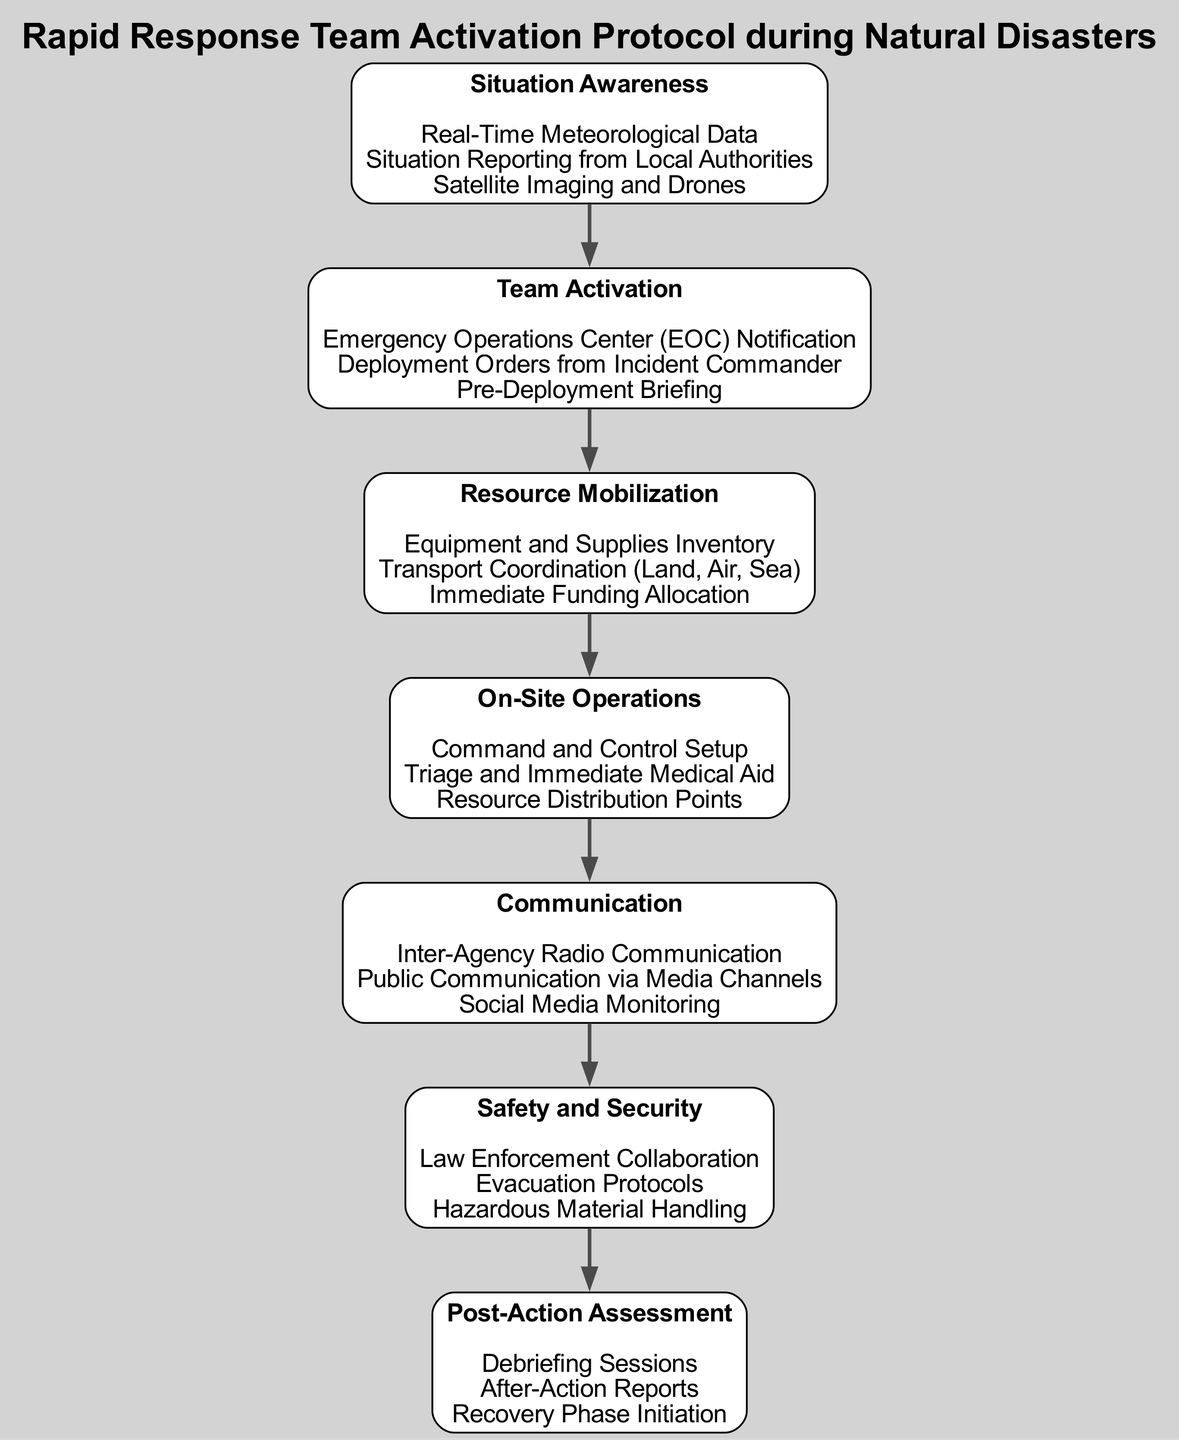What is the first step in the diagram? The first step in the diagram is "Situation Awareness." It is the initial node that starts the process.
Answer: Situation Awareness How many details are listed under "Team Activation"? There are three details listed under "Team Activation." These are all the points that describe the activation of the team in the protocol.
Answer: 3 What are the types of resources mentioned in "Resource Mobilization"? The types of resources mentioned are "Equipment and Supplies Inventory," "Transport Coordination," and "Immediate Funding Allocation." Each detail indicates a need for mobilizing various types of resources during a natural disaster response.
Answer: Equipment and Supplies Inventory, Transport Coordination, Immediate Funding Allocation Which element follows "On-Site Operations"? The element that follows "On-Site Operations" is "Communication." The flow of the diagram moves from on-site activities to ensuring effective communication is established.
Answer: Communication What is the last step in the process detailed in the diagram? The last step in the process is "Post-Action Assessment." It completes the cycle of the protocol by focusing on evaluating the response after the actions have been taken.
Answer: Post-Action Assessment Which two elements are directly connected in the diagram? The two elements that are directly connected are "Resource Mobilization" and "On-Site Operations." This indicates that after resources are mobilized, on-site operations begin.
Answer: Resource Mobilization, On-Site Operations What type of communication is emphasized under "Communication"? The type of communication emphasized is "Inter-Agency Radio Communication." This detail shows the importance of coordinated communication among agencies during a response.
Answer: Inter-Agency Radio Communication What does "Situation Reporting" refer to? "Situation Reporting" refers to the updates and information received from local authorities regarding the status of a disaster, which is crucial for situational awareness.
Answer: Situation Reporting from Local Authorities How is safety ensured according to the protocol? Safety is ensured by "Law Enforcement Collaboration," "Evacuation Protocols," and "Hazardous Material Handling," indicating a multi-faceted approach to security during disasters.
Answer: Law Enforcement Collaboration, Evacuation Protocols, Hazardous Material Handling 